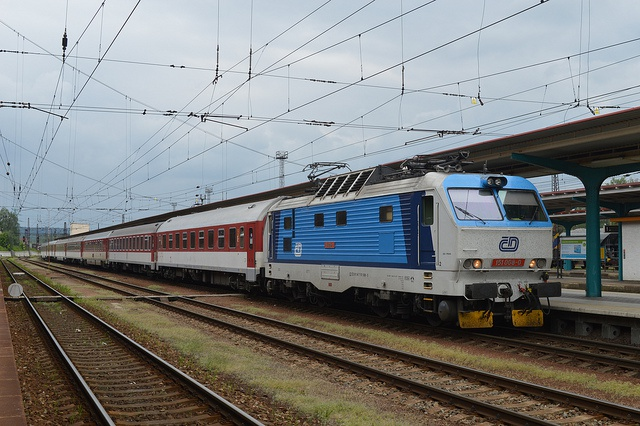Describe the objects in this image and their specific colors. I can see a train in lightgray, black, darkgray, gray, and blue tones in this image. 